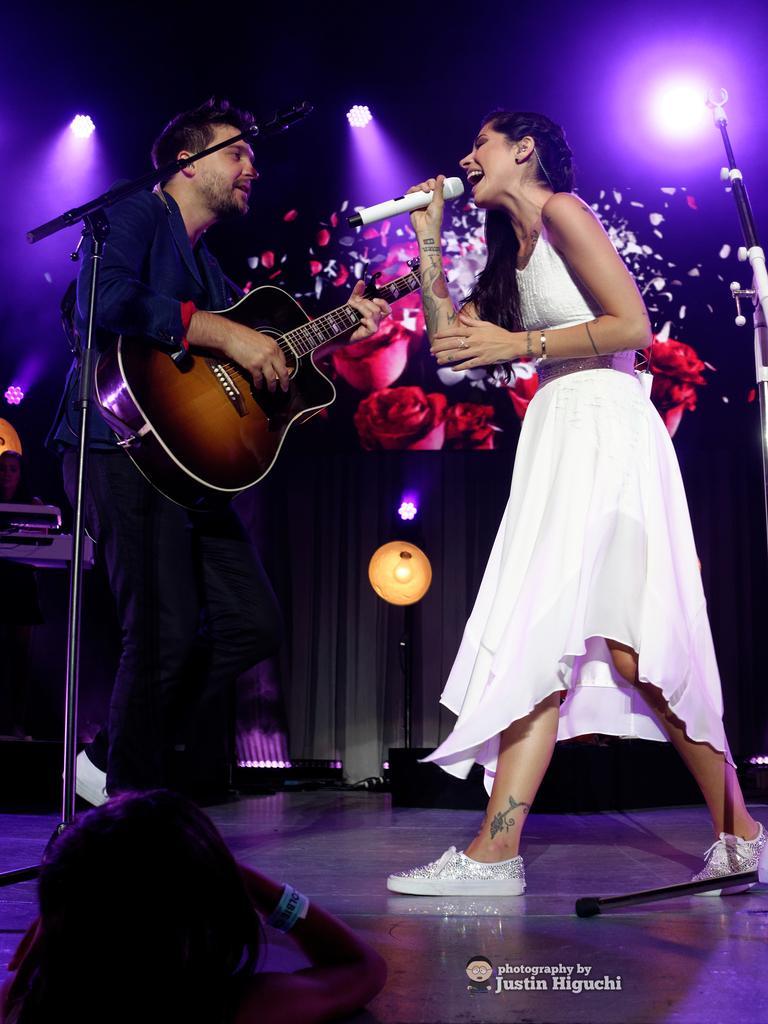In one or two sentences, can you explain what this image depicts? As we can see in the image there are two people on stage. The man who is standing here is holding guitar in his hand. In front of him there is a mic and the woman is holding mic in her hand and singing. 